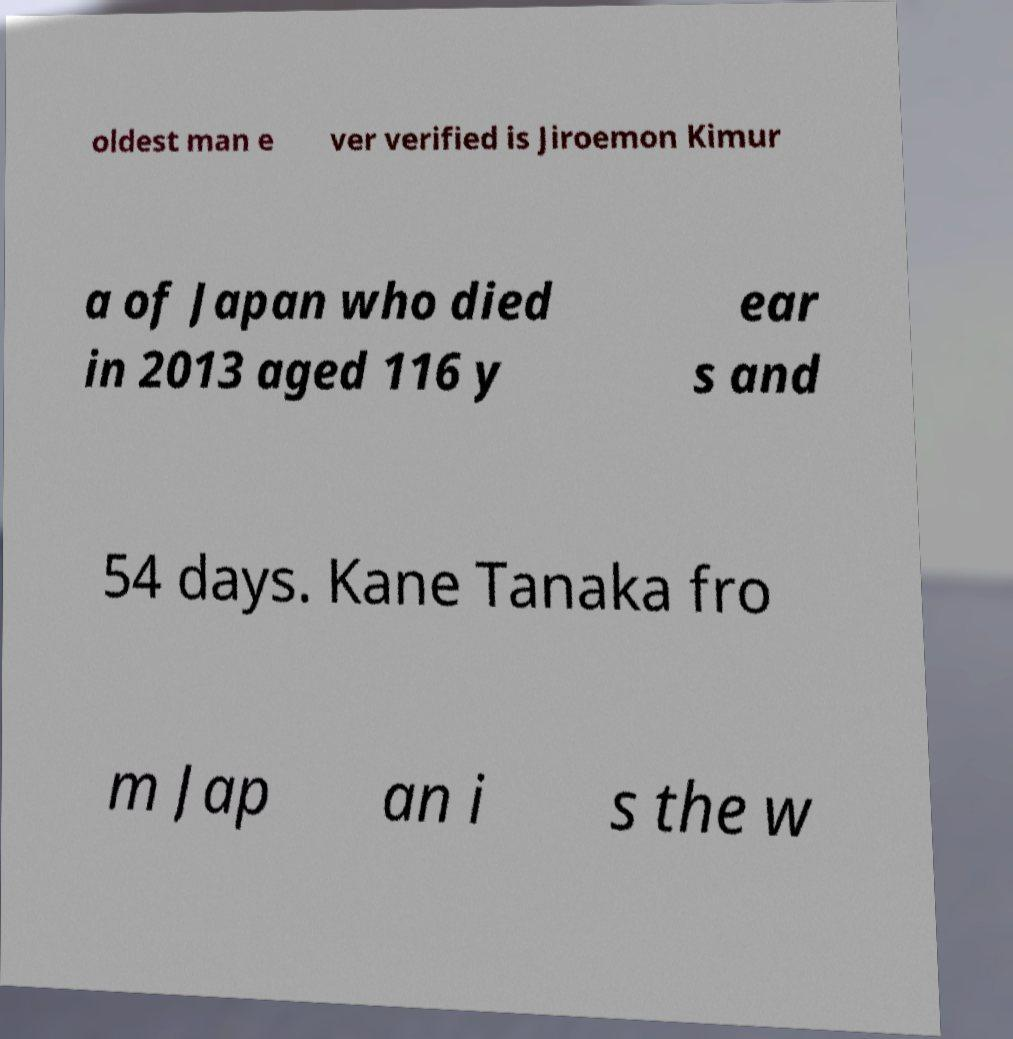Could you extract and type out the text from this image? oldest man e ver verified is Jiroemon Kimur a of Japan who died in 2013 aged 116 y ear s and 54 days. Kane Tanaka fro m Jap an i s the w 